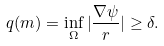<formula> <loc_0><loc_0><loc_500><loc_500>q ( m ) = \inf _ { \Omega } | \frac { \nabla \psi } { r } | \geq \delta .</formula> 